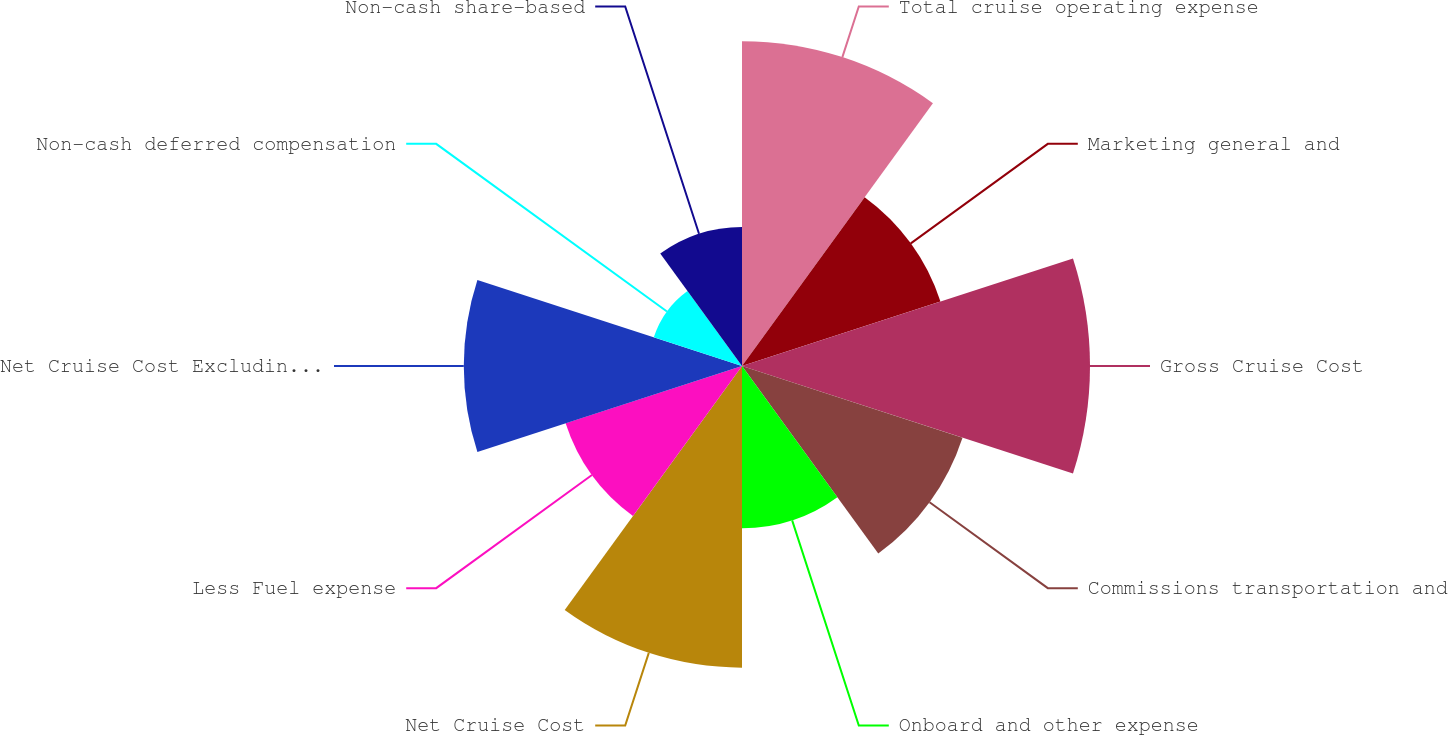Convert chart. <chart><loc_0><loc_0><loc_500><loc_500><pie_chart><fcel>Total cruise operating expense<fcel>Marketing general and<fcel>Gross Cruise Cost<fcel>Commissions transportation and<fcel>Onboard and other expense<fcel>Net Cruise Cost<fcel>Less Fuel expense<fcel>Net Cruise Cost Excluding Fuel<fcel>Non-cash deferred compensation<fcel>Non-cash share-based<nl><fcel>14.29%<fcel>9.18%<fcel>15.31%<fcel>10.2%<fcel>7.14%<fcel>13.27%<fcel>8.16%<fcel>12.24%<fcel>4.08%<fcel>6.12%<nl></chart> 